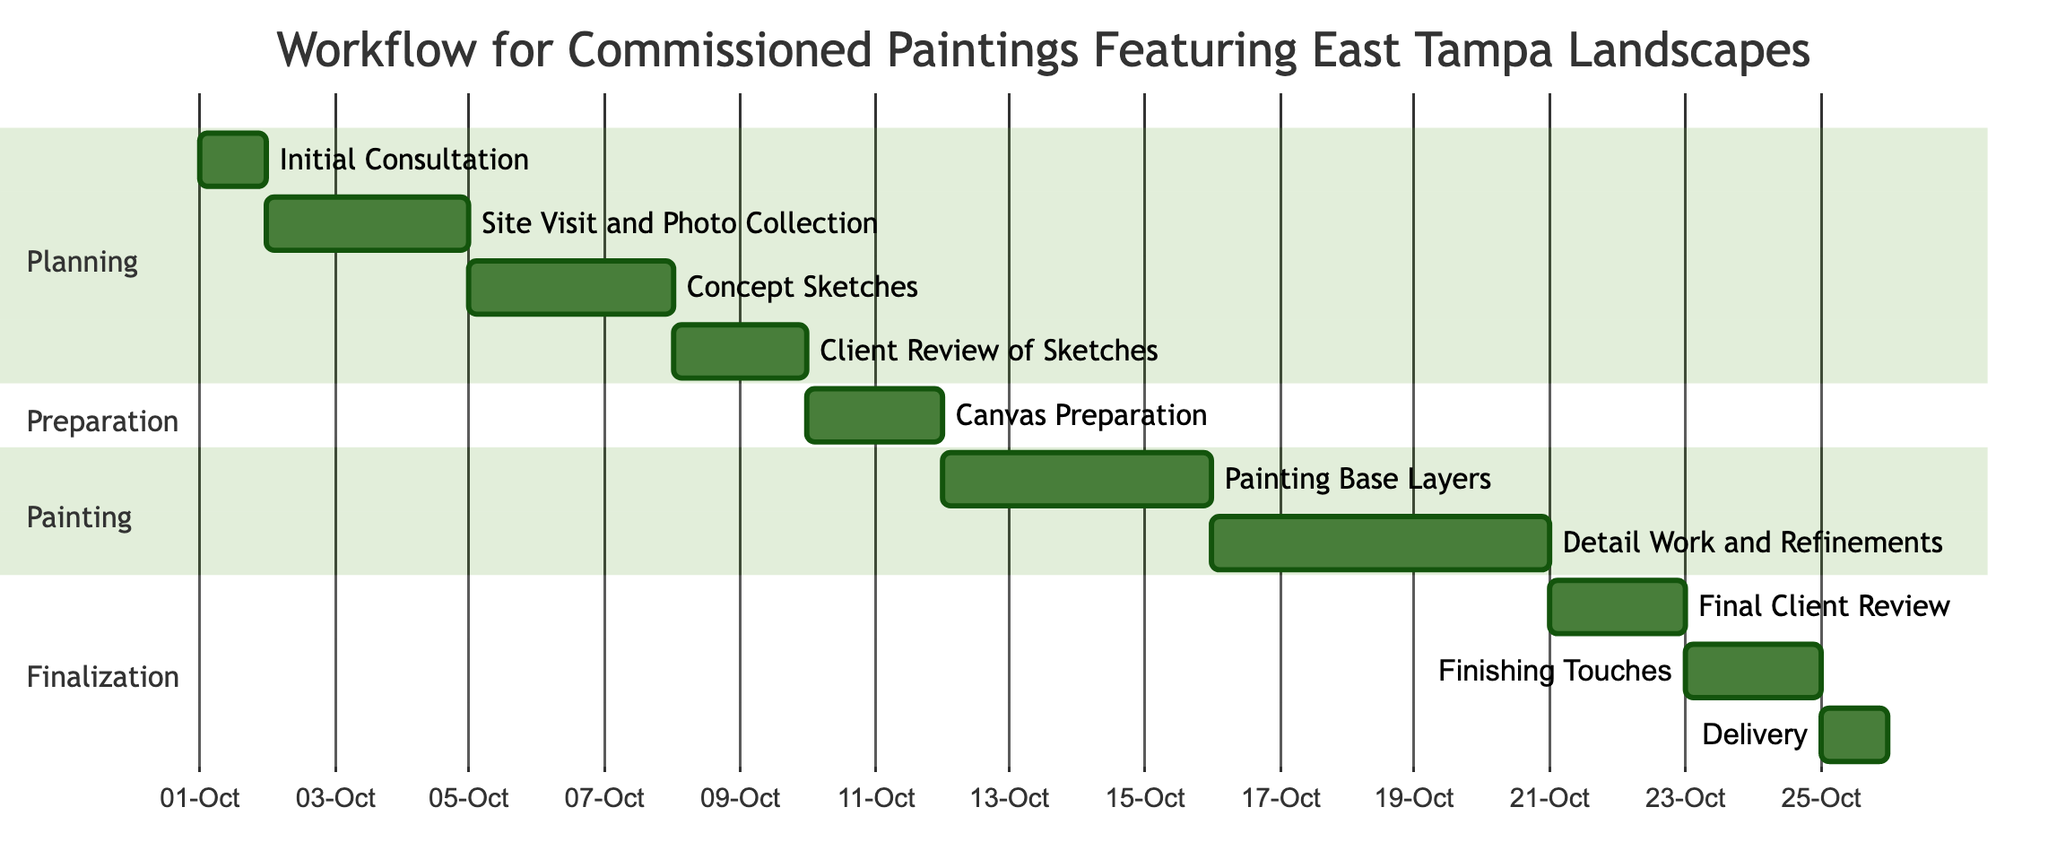What is the start date of the "Detail Work and Refinements"? According to the Gantt chart, the "Detail Work and Refinements" task starts on October 16, 2023.
Answer: October 16, 2023 How many days is the "Client Review of Sketches"? The "Client Review of Sketches" task spans from October 8 to October 9, which is a duration of 2 days.
Answer: 2 days What task follows "Canvas Preparation"? The "Painting Base Layers" task immediately follows "Canvas Preparation," starting on October 12, 2023.
Answer: Painting Base Layers Which section contains the task "Final Client Review"? The "Final Client Review" is located in the "Finalization" section of the Gantt chart.
Answer: Finalization What is the total duration of the entire workflow? The workflow starts on October 1, 2023, and ends on October 25, 2023, resulting in a total duration of 25 days.
Answer: 25 days How many tasks are involved in the "Preparation" section? The "Preparation" section consists of 1 task, which is "Canvas Preparation."
Answer: 1 task What date does the "Delivery" task occur? The "Delivery" task is scheduled for October 25, 2023, according to the Gantt chart.
Answer: October 25, 2023 Which task has the longest duration in the Painting section? The "Detail Work and Refinements" task in the Painting section spans 5 days, making it the longest in that section.
Answer: 5 days What is the relationship between "Concept Sketches" and "Client Review of Sketches"? "Concept Sketches" must be completed before the "Client Review of Sketches" can begin, indicating a dependent relationship.
Answer: Dependent relationship 